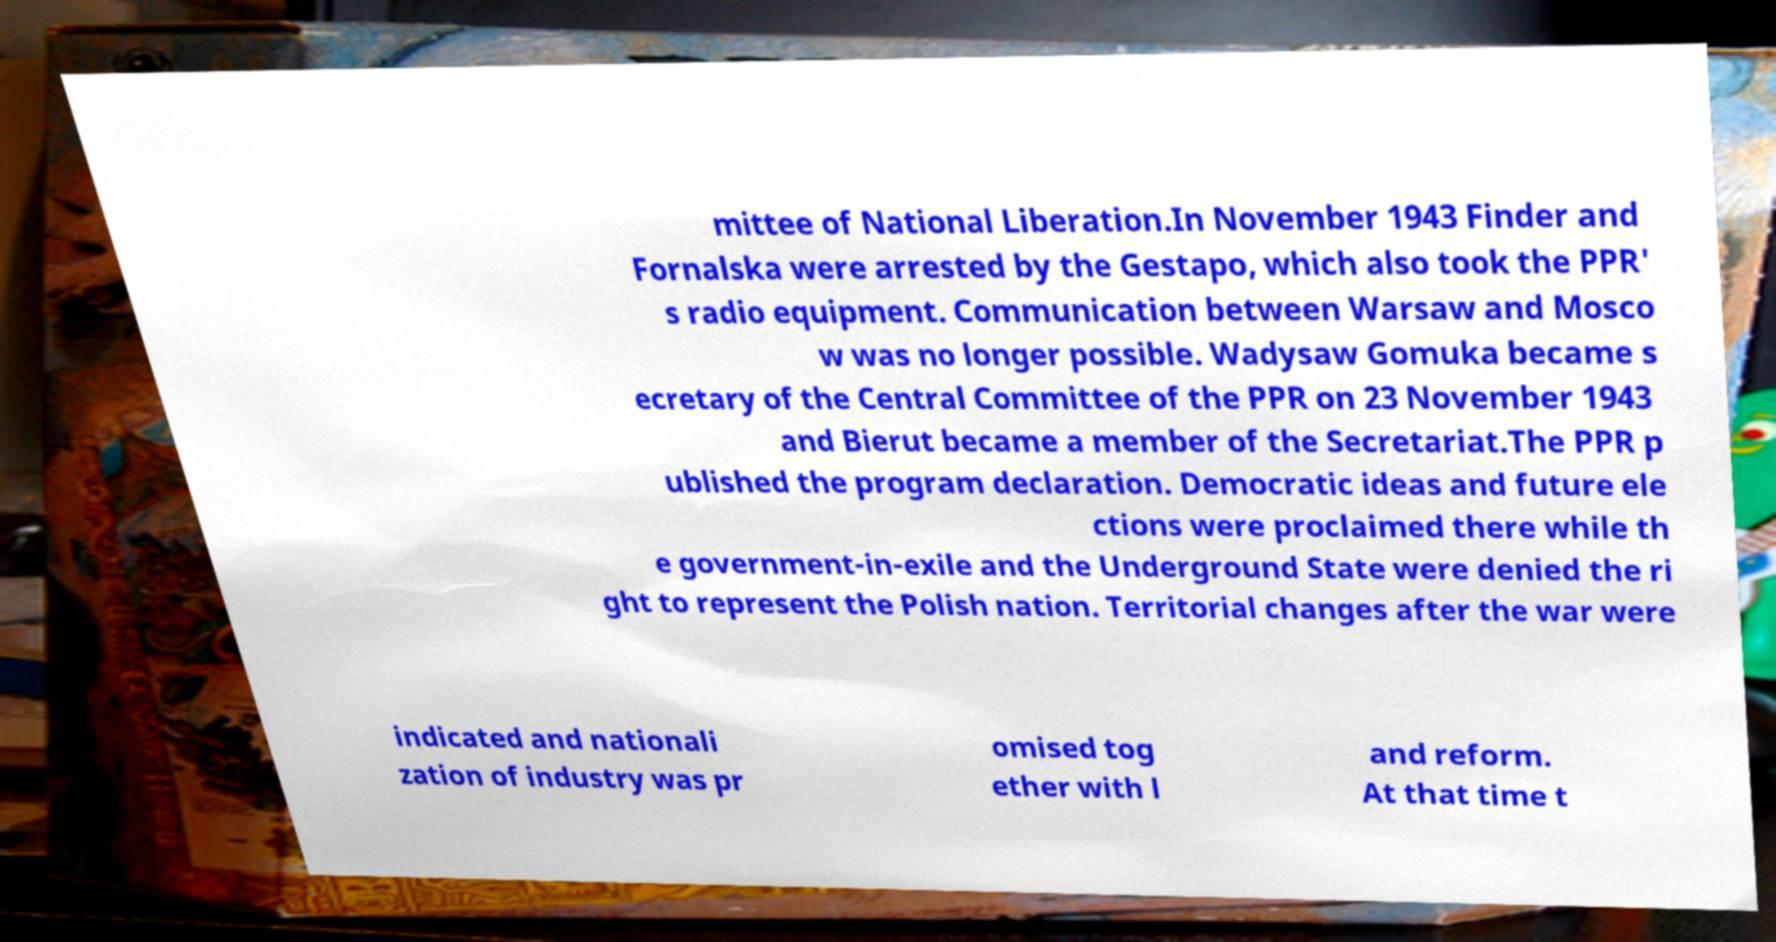Can you read and provide the text displayed in the image?This photo seems to have some interesting text. Can you extract and type it out for me? mittee of National Liberation.In November 1943 Finder and Fornalska were arrested by the Gestapo, which also took the PPR' s radio equipment. Communication between Warsaw and Mosco w was no longer possible. Wadysaw Gomuka became s ecretary of the Central Committee of the PPR on 23 November 1943 and Bierut became a member of the Secretariat.The PPR p ublished the program declaration. Democratic ideas and future ele ctions were proclaimed there while th e government-in-exile and the Underground State were denied the ri ght to represent the Polish nation. Territorial changes after the war were indicated and nationali zation of industry was pr omised tog ether with l and reform. At that time t 